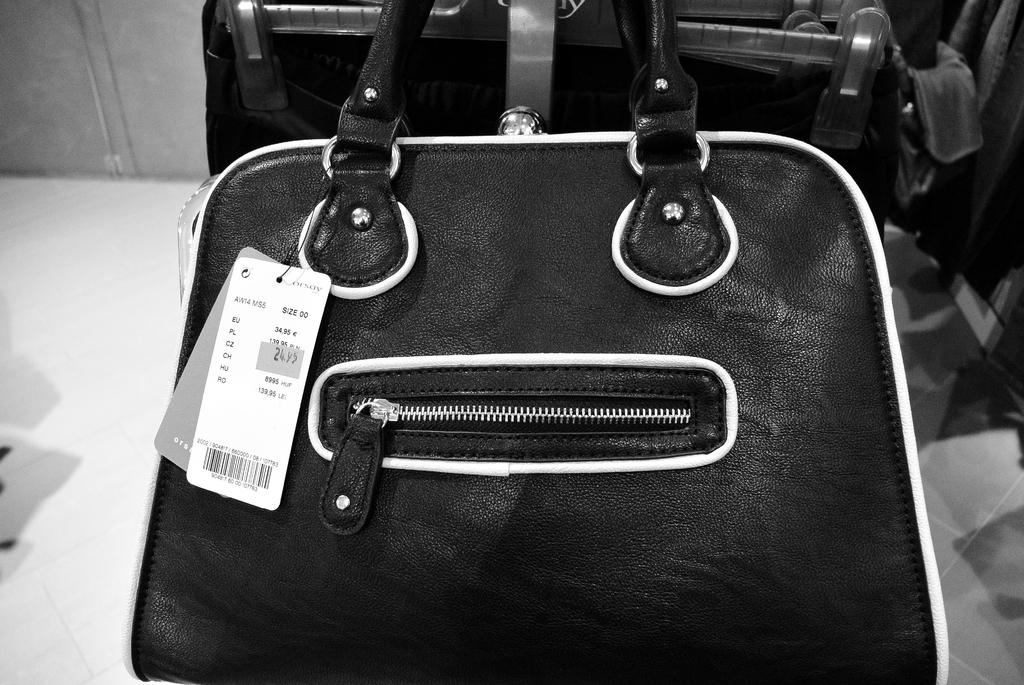What object can be seen in the picture? There is a bag in the picture. What is the color of the bag? The bag is black in color. Is there any feature on the bag that allows it to be closed? Yes, there is a zip in the middle of the bag. Is there any information about the bag's price visible in the image? Yes, there is a price tag on the bag. What type of teeth can be seen on the bag in the image? There are no teeth visible on the bag in the image. Can you describe the skateboard that is leaning against the bag? There is no skateboard present in the image; it only features a black bag with a zip and a price tag. 